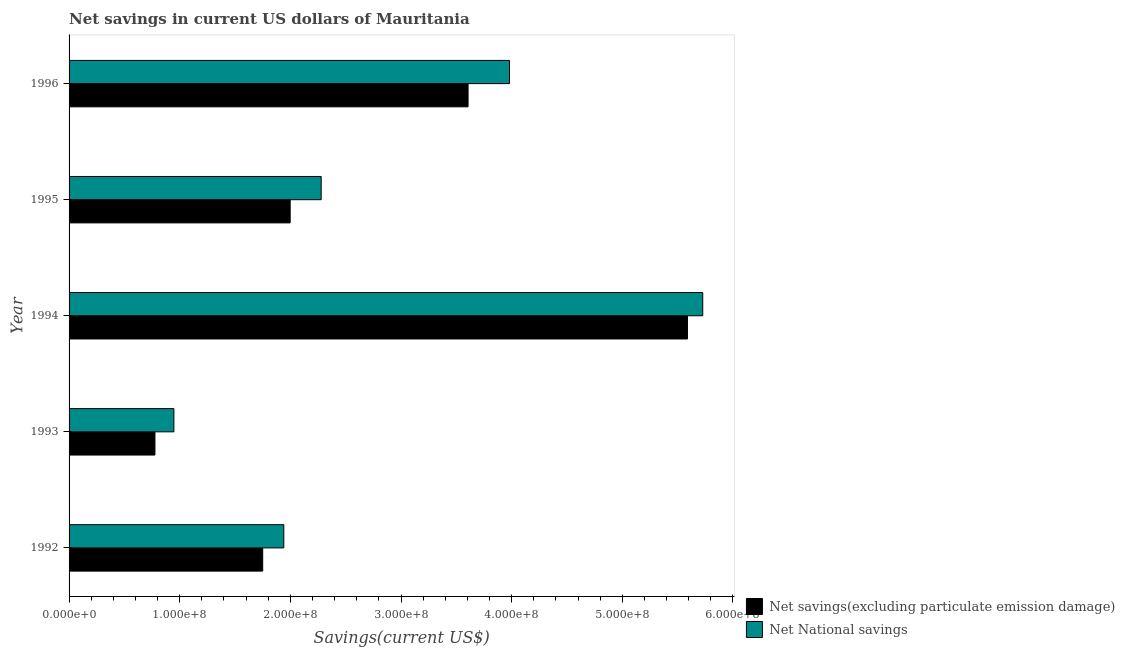How many different coloured bars are there?
Your answer should be compact. 2. Are the number of bars on each tick of the Y-axis equal?
Make the answer very short. Yes. How many bars are there on the 5th tick from the top?
Keep it short and to the point. 2. How many bars are there on the 5th tick from the bottom?
Give a very brief answer. 2. What is the label of the 3rd group of bars from the top?
Provide a short and direct response. 1994. In how many cases, is the number of bars for a given year not equal to the number of legend labels?
Give a very brief answer. 0. What is the net national savings in 1994?
Offer a terse response. 5.73e+08. Across all years, what is the maximum net savings(excluding particulate emission damage)?
Give a very brief answer. 5.59e+08. Across all years, what is the minimum net national savings?
Ensure brevity in your answer.  9.47e+07. What is the total net national savings in the graph?
Your response must be concise. 1.49e+09. What is the difference between the net savings(excluding particulate emission damage) in 1994 and that in 1996?
Your response must be concise. 1.98e+08. What is the difference between the net savings(excluding particulate emission damage) in 1995 and the net national savings in 1994?
Make the answer very short. -3.73e+08. What is the average net national savings per year?
Provide a succinct answer. 2.97e+08. In the year 1993, what is the difference between the net national savings and net savings(excluding particulate emission damage)?
Offer a terse response. 1.71e+07. What is the ratio of the net national savings in 1993 to that in 1995?
Offer a terse response. 0.42. Is the difference between the net savings(excluding particulate emission damage) in 1992 and 1996 greater than the difference between the net national savings in 1992 and 1996?
Offer a very short reply. Yes. What is the difference between the highest and the second highest net savings(excluding particulate emission damage)?
Give a very brief answer. 1.98e+08. What is the difference between the highest and the lowest net savings(excluding particulate emission damage)?
Offer a very short reply. 4.81e+08. Is the sum of the net savings(excluding particulate emission damage) in 1992 and 1995 greater than the maximum net national savings across all years?
Make the answer very short. No. What does the 1st bar from the top in 1995 represents?
Give a very brief answer. Net National savings. What does the 1st bar from the bottom in 1995 represents?
Provide a succinct answer. Net savings(excluding particulate emission damage). How many years are there in the graph?
Offer a terse response. 5. Are the values on the major ticks of X-axis written in scientific E-notation?
Ensure brevity in your answer.  Yes. Does the graph contain grids?
Provide a succinct answer. No. Where does the legend appear in the graph?
Make the answer very short. Bottom right. How many legend labels are there?
Your response must be concise. 2. How are the legend labels stacked?
Your response must be concise. Vertical. What is the title of the graph?
Your answer should be compact. Net savings in current US dollars of Mauritania. Does "ODA received" appear as one of the legend labels in the graph?
Make the answer very short. No. What is the label or title of the X-axis?
Give a very brief answer. Savings(current US$). What is the Savings(current US$) in Net savings(excluding particulate emission damage) in 1992?
Ensure brevity in your answer.  1.75e+08. What is the Savings(current US$) of Net National savings in 1992?
Keep it short and to the point. 1.94e+08. What is the Savings(current US$) in Net savings(excluding particulate emission damage) in 1993?
Provide a succinct answer. 7.76e+07. What is the Savings(current US$) of Net National savings in 1993?
Provide a short and direct response. 9.47e+07. What is the Savings(current US$) of Net savings(excluding particulate emission damage) in 1994?
Your answer should be compact. 5.59e+08. What is the Savings(current US$) of Net National savings in 1994?
Your answer should be very brief. 5.73e+08. What is the Savings(current US$) in Net savings(excluding particulate emission damage) in 1995?
Give a very brief answer. 2.00e+08. What is the Savings(current US$) in Net National savings in 1995?
Make the answer very short. 2.28e+08. What is the Savings(current US$) in Net savings(excluding particulate emission damage) in 1996?
Your answer should be compact. 3.61e+08. What is the Savings(current US$) of Net National savings in 1996?
Provide a short and direct response. 3.98e+08. Across all years, what is the maximum Savings(current US$) of Net savings(excluding particulate emission damage)?
Your answer should be compact. 5.59e+08. Across all years, what is the maximum Savings(current US$) of Net National savings?
Keep it short and to the point. 5.73e+08. Across all years, what is the minimum Savings(current US$) of Net savings(excluding particulate emission damage)?
Make the answer very short. 7.76e+07. Across all years, what is the minimum Savings(current US$) of Net National savings?
Give a very brief answer. 9.47e+07. What is the total Savings(current US$) of Net savings(excluding particulate emission damage) in the graph?
Your answer should be compact. 1.37e+09. What is the total Savings(current US$) of Net National savings in the graph?
Offer a terse response. 1.49e+09. What is the difference between the Savings(current US$) in Net savings(excluding particulate emission damage) in 1992 and that in 1993?
Keep it short and to the point. 9.74e+07. What is the difference between the Savings(current US$) in Net National savings in 1992 and that in 1993?
Make the answer very short. 9.93e+07. What is the difference between the Savings(current US$) in Net savings(excluding particulate emission damage) in 1992 and that in 1994?
Your answer should be very brief. -3.84e+08. What is the difference between the Savings(current US$) of Net National savings in 1992 and that in 1994?
Provide a short and direct response. -3.79e+08. What is the difference between the Savings(current US$) of Net savings(excluding particulate emission damage) in 1992 and that in 1995?
Offer a terse response. -2.48e+07. What is the difference between the Savings(current US$) in Net National savings in 1992 and that in 1995?
Your answer should be compact. -3.38e+07. What is the difference between the Savings(current US$) of Net savings(excluding particulate emission damage) in 1992 and that in 1996?
Provide a succinct answer. -1.86e+08. What is the difference between the Savings(current US$) in Net National savings in 1992 and that in 1996?
Keep it short and to the point. -2.04e+08. What is the difference between the Savings(current US$) of Net savings(excluding particulate emission damage) in 1993 and that in 1994?
Offer a terse response. -4.81e+08. What is the difference between the Savings(current US$) in Net National savings in 1993 and that in 1994?
Give a very brief answer. -4.78e+08. What is the difference between the Savings(current US$) in Net savings(excluding particulate emission damage) in 1993 and that in 1995?
Ensure brevity in your answer.  -1.22e+08. What is the difference between the Savings(current US$) of Net National savings in 1993 and that in 1995?
Provide a short and direct response. -1.33e+08. What is the difference between the Savings(current US$) of Net savings(excluding particulate emission damage) in 1993 and that in 1996?
Ensure brevity in your answer.  -2.83e+08. What is the difference between the Savings(current US$) of Net National savings in 1993 and that in 1996?
Your response must be concise. -3.03e+08. What is the difference between the Savings(current US$) in Net savings(excluding particulate emission damage) in 1994 and that in 1995?
Keep it short and to the point. 3.59e+08. What is the difference between the Savings(current US$) of Net National savings in 1994 and that in 1995?
Give a very brief answer. 3.45e+08. What is the difference between the Savings(current US$) in Net savings(excluding particulate emission damage) in 1994 and that in 1996?
Provide a short and direct response. 1.98e+08. What is the difference between the Savings(current US$) in Net National savings in 1994 and that in 1996?
Ensure brevity in your answer.  1.75e+08. What is the difference between the Savings(current US$) in Net savings(excluding particulate emission damage) in 1995 and that in 1996?
Ensure brevity in your answer.  -1.61e+08. What is the difference between the Savings(current US$) of Net National savings in 1995 and that in 1996?
Keep it short and to the point. -1.70e+08. What is the difference between the Savings(current US$) in Net savings(excluding particulate emission damage) in 1992 and the Savings(current US$) in Net National savings in 1993?
Keep it short and to the point. 8.03e+07. What is the difference between the Savings(current US$) of Net savings(excluding particulate emission damage) in 1992 and the Savings(current US$) of Net National savings in 1994?
Ensure brevity in your answer.  -3.98e+08. What is the difference between the Savings(current US$) in Net savings(excluding particulate emission damage) in 1992 and the Savings(current US$) in Net National savings in 1995?
Your answer should be compact. -5.29e+07. What is the difference between the Savings(current US$) in Net savings(excluding particulate emission damage) in 1992 and the Savings(current US$) in Net National savings in 1996?
Your response must be concise. -2.23e+08. What is the difference between the Savings(current US$) of Net savings(excluding particulate emission damage) in 1993 and the Savings(current US$) of Net National savings in 1994?
Your response must be concise. -4.95e+08. What is the difference between the Savings(current US$) in Net savings(excluding particulate emission damage) in 1993 and the Savings(current US$) in Net National savings in 1995?
Ensure brevity in your answer.  -1.50e+08. What is the difference between the Savings(current US$) in Net savings(excluding particulate emission damage) in 1993 and the Savings(current US$) in Net National savings in 1996?
Offer a very short reply. -3.20e+08. What is the difference between the Savings(current US$) of Net savings(excluding particulate emission damage) in 1994 and the Savings(current US$) of Net National savings in 1995?
Offer a very short reply. 3.31e+08. What is the difference between the Savings(current US$) of Net savings(excluding particulate emission damage) in 1994 and the Savings(current US$) of Net National savings in 1996?
Provide a succinct answer. 1.61e+08. What is the difference between the Savings(current US$) of Net savings(excluding particulate emission damage) in 1995 and the Savings(current US$) of Net National savings in 1996?
Offer a very short reply. -1.98e+08. What is the average Savings(current US$) in Net savings(excluding particulate emission damage) per year?
Provide a short and direct response. 2.74e+08. What is the average Savings(current US$) of Net National savings per year?
Make the answer very short. 2.97e+08. In the year 1992, what is the difference between the Savings(current US$) of Net savings(excluding particulate emission damage) and Savings(current US$) of Net National savings?
Your response must be concise. -1.91e+07. In the year 1993, what is the difference between the Savings(current US$) in Net savings(excluding particulate emission damage) and Savings(current US$) in Net National savings?
Provide a short and direct response. -1.71e+07. In the year 1994, what is the difference between the Savings(current US$) in Net savings(excluding particulate emission damage) and Savings(current US$) in Net National savings?
Provide a short and direct response. -1.38e+07. In the year 1995, what is the difference between the Savings(current US$) of Net savings(excluding particulate emission damage) and Savings(current US$) of Net National savings?
Ensure brevity in your answer.  -2.80e+07. In the year 1996, what is the difference between the Savings(current US$) of Net savings(excluding particulate emission damage) and Savings(current US$) of Net National savings?
Offer a very short reply. -3.74e+07. What is the ratio of the Savings(current US$) of Net savings(excluding particulate emission damage) in 1992 to that in 1993?
Your answer should be very brief. 2.25. What is the ratio of the Savings(current US$) of Net National savings in 1992 to that in 1993?
Keep it short and to the point. 2.05. What is the ratio of the Savings(current US$) in Net savings(excluding particulate emission damage) in 1992 to that in 1994?
Provide a succinct answer. 0.31. What is the ratio of the Savings(current US$) of Net National savings in 1992 to that in 1994?
Keep it short and to the point. 0.34. What is the ratio of the Savings(current US$) of Net savings(excluding particulate emission damage) in 1992 to that in 1995?
Your answer should be compact. 0.88. What is the ratio of the Savings(current US$) of Net National savings in 1992 to that in 1995?
Offer a very short reply. 0.85. What is the ratio of the Savings(current US$) in Net savings(excluding particulate emission damage) in 1992 to that in 1996?
Your response must be concise. 0.49. What is the ratio of the Savings(current US$) in Net National savings in 1992 to that in 1996?
Your response must be concise. 0.49. What is the ratio of the Savings(current US$) of Net savings(excluding particulate emission damage) in 1993 to that in 1994?
Give a very brief answer. 0.14. What is the ratio of the Savings(current US$) in Net National savings in 1993 to that in 1994?
Your answer should be compact. 0.17. What is the ratio of the Savings(current US$) of Net savings(excluding particulate emission damage) in 1993 to that in 1995?
Keep it short and to the point. 0.39. What is the ratio of the Savings(current US$) of Net National savings in 1993 to that in 1995?
Provide a short and direct response. 0.42. What is the ratio of the Savings(current US$) of Net savings(excluding particulate emission damage) in 1993 to that in 1996?
Your answer should be very brief. 0.22. What is the ratio of the Savings(current US$) in Net National savings in 1993 to that in 1996?
Your response must be concise. 0.24. What is the ratio of the Savings(current US$) of Net savings(excluding particulate emission damage) in 1994 to that in 1995?
Offer a very short reply. 2.8. What is the ratio of the Savings(current US$) of Net National savings in 1994 to that in 1995?
Offer a very short reply. 2.51. What is the ratio of the Savings(current US$) of Net savings(excluding particulate emission damage) in 1994 to that in 1996?
Offer a very short reply. 1.55. What is the ratio of the Savings(current US$) in Net National savings in 1994 to that in 1996?
Keep it short and to the point. 1.44. What is the ratio of the Savings(current US$) in Net savings(excluding particulate emission damage) in 1995 to that in 1996?
Your response must be concise. 0.55. What is the ratio of the Savings(current US$) in Net National savings in 1995 to that in 1996?
Offer a terse response. 0.57. What is the difference between the highest and the second highest Savings(current US$) in Net savings(excluding particulate emission damage)?
Your answer should be very brief. 1.98e+08. What is the difference between the highest and the second highest Savings(current US$) of Net National savings?
Keep it short and to the point. 1.75e+08. What is the difference between the highest and the lowest Savings(current US$) in Net savings(excluding particulate emission damage)?
Provide a short and direct response. 4.81e+08. What is the difference between the highest and the lowest Savings(current US$) of Net National savings?
Provide a short and direct response. 4.78e+08. 